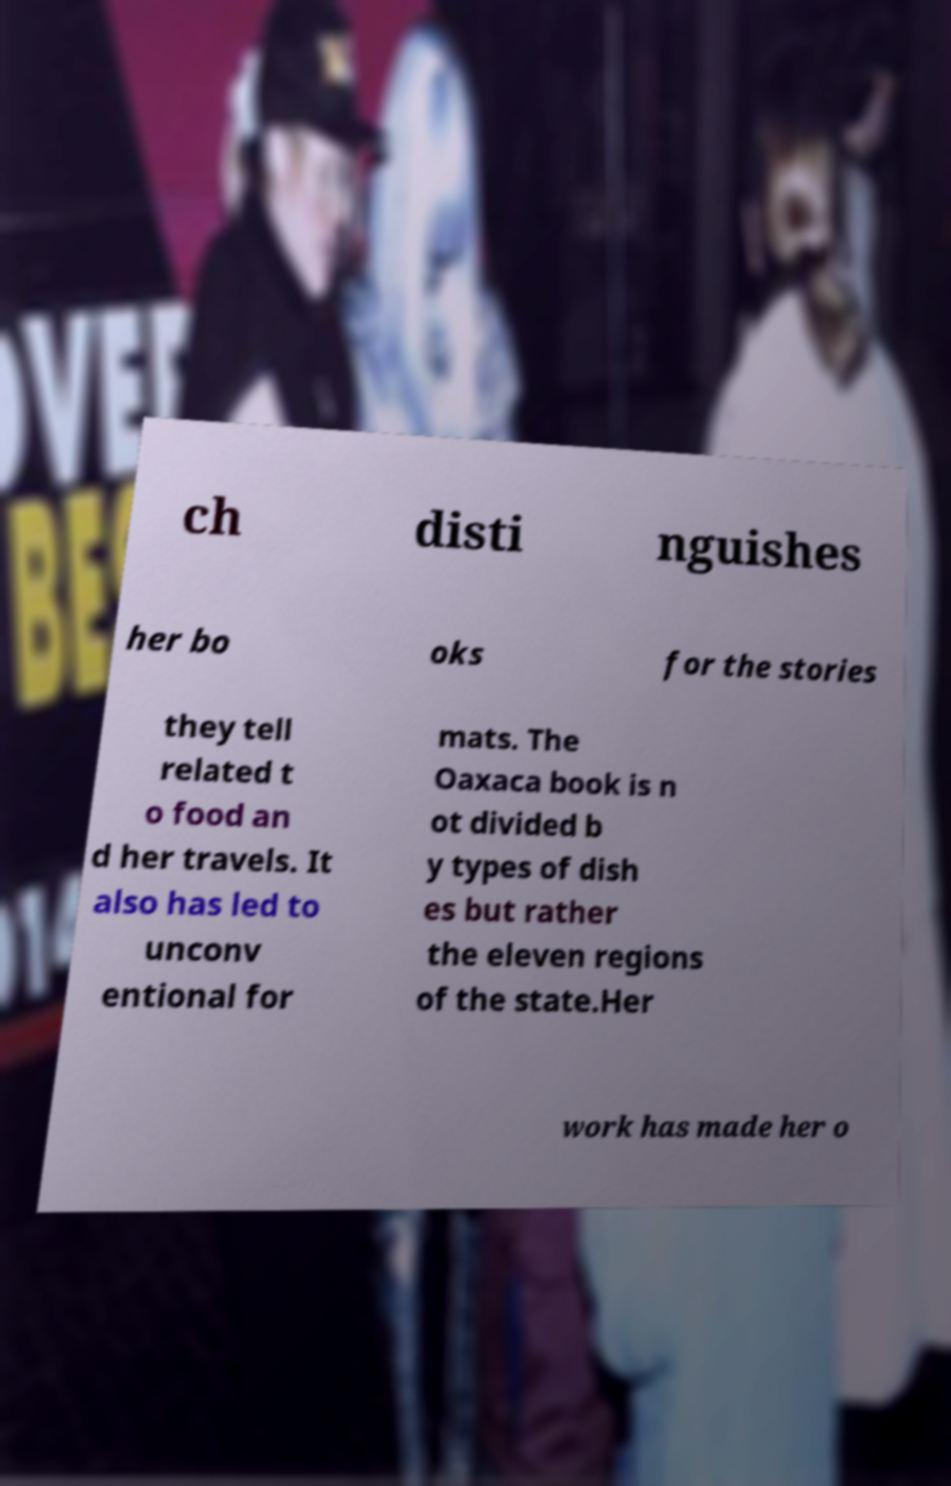Could you extract and type out the text from this image? ch disti nguishes her bo oks for the stories they tell related t o food an d her travels. It also has led to unconv entional for mats. The Oaxaca book is n ot divided b y types of dish es but rather the eleven regions of the state.Her work has made her o 